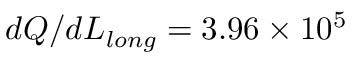<formula> <loc_0><loc_0><loc_500><loc_500>d Q / d L _ { l o n g } = 3 . 9 6 \times 1 0 ^ { 5 }</formula> 